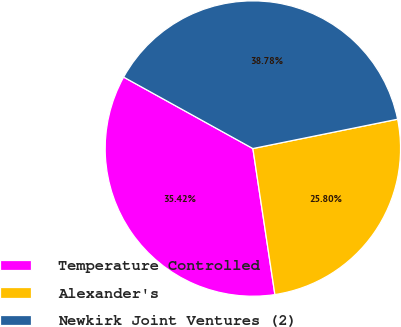Convert chart. <chart><loc_0><loc_0><loc_500><loc_500><pie_chart><fcel>Temperature Controlled<fcel>Alexander's<fcel>Newkirk Joint Ventures (2)<nl><fcel>35.42%<fcel>25.8%<fcel>38.78%<nl></chart> 